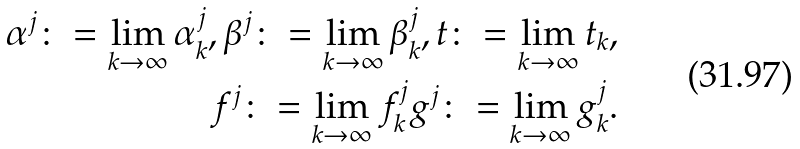Convert formula to latex. <formula><loc_0><loc_0><loc_500><loc_500>\alpha ^ { j } \colon = \lim _ { k \to \infty } \alpha ^ { j } _ { k } , \beta ^ { j } \colon = \lim _ { k \to \infty } \beta ^ { j } _ { k } , t \colon = \lim _ { k \to \infty } t _ { k } , \\ f ^ { j } \colon = \lim _ { k \to \infty } f ^ { j } _ { k } g ^ { j } \colon = \lim _ { k \to \infty } g ^ { j } _ { k } .</formula> 